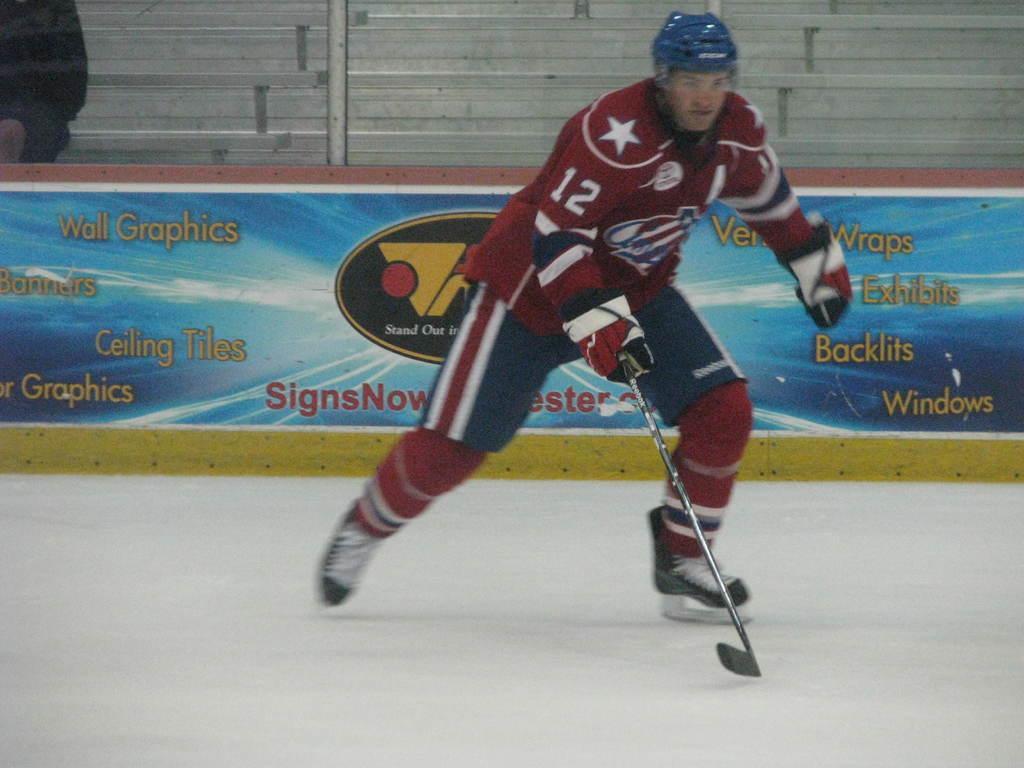Describe this image in one or two sentences. In this image I can see a person wearing brown, white and blue colored dress is ice-skating holding a hockey stick in his hand. In the background I can see a blue colored board, few benches and a person sitting on a bench. 